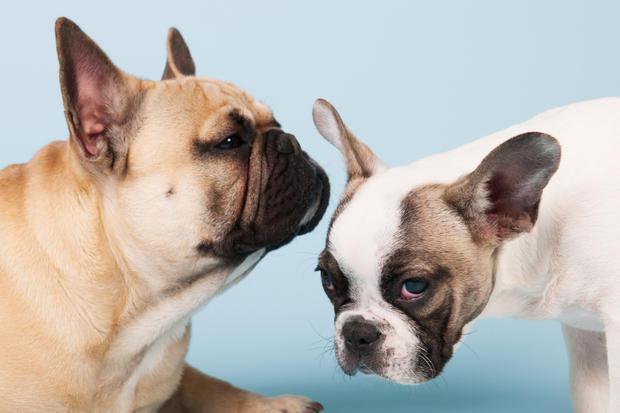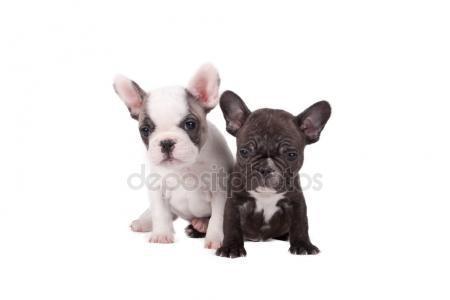The first image is the image on the left, the second image is the image on the right. Given the left and right images, does the statement "In one image, two dogs are touching one another, with at least one of the dogs touching the other with its mouth" hold true? Answer yes or no. No. 